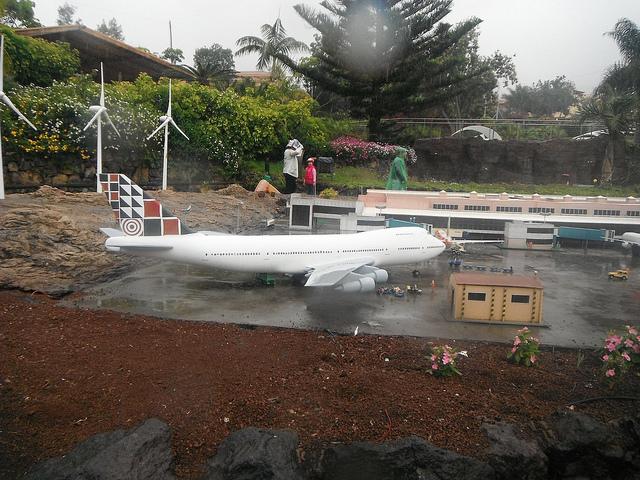What kind of weather is here?
Give a very brief answer. Rainy. Are any of these items toys?
Write a very short answer. Yes. Is the plane flooded?
Give a very brief answer. No. 